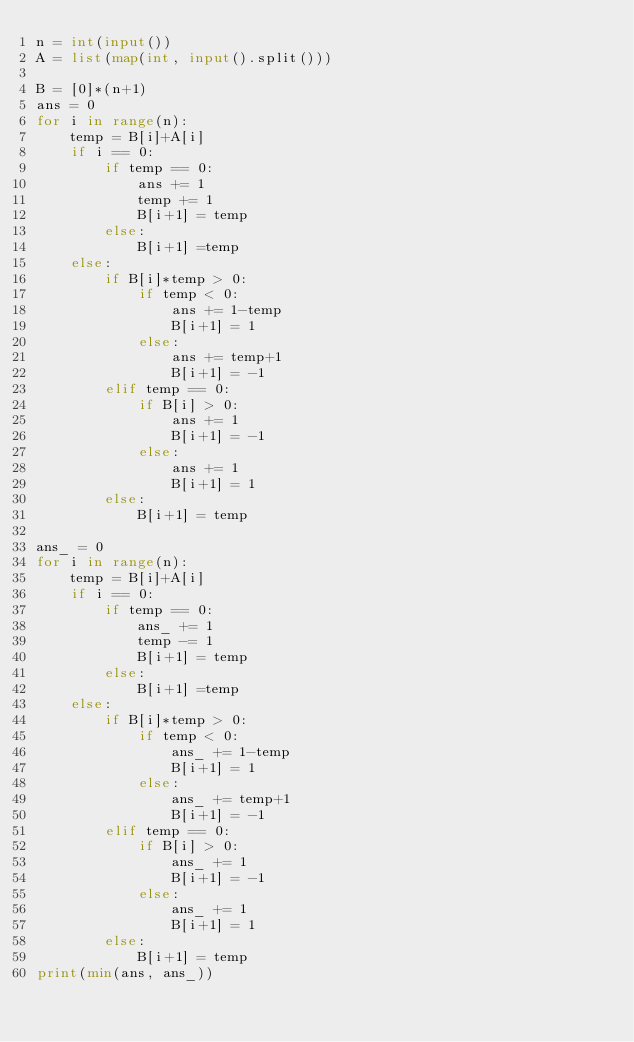<code> <loc_0><loc_0><loc_500><loc_500><_Python_>n = int(input())
A = list(map(int, input().split()))

B = [0]*(n+1)
ans = 0
for i in range(n):
    temp = B[i]+A[i]
    if i == 0:
        if temp == 0:
            ans += 1
            temp += 1
            B[i+1] = temp
        else:
            B[i+1] =temp
    else:
        if B[i]*temp > 0:
            if temp < 0:
                ans += 1-temp
                B[i+1] = 1
            else:
                ans += temp+1
                B[i+1] = -1
        elif temp == 0:
            if B[i] > 0:
                ans += 1
                B[i+1] = -1
            else:
                ans += 1
                B[i+1] = 1
        else:
            B[i+1] = temp

ans_ = 0
for i in range(n):
    temp = B[i]+A[i]
    if i == 0:
        if temp == 0:
            ans_ += 1
            temp -= 1
            B[i+1] = temp
        else:
            B[i+1] =temp
    else:
        if B[i]*temp > 0:
            if temp < 0:
                ans_ += 1-temp
                B[i+1] = 1
            else:
                ans_ += temp+1
                B[i+1] = -1
        elif temp == 0:
            if B[i] > 0:
                ans_ += 1
                B[i+1] = -1
            else:
                ans_ += 1
                B[i+1] = 1
        else:
            B[i+1] = temp
print(min(ans, ans_))
</code> 